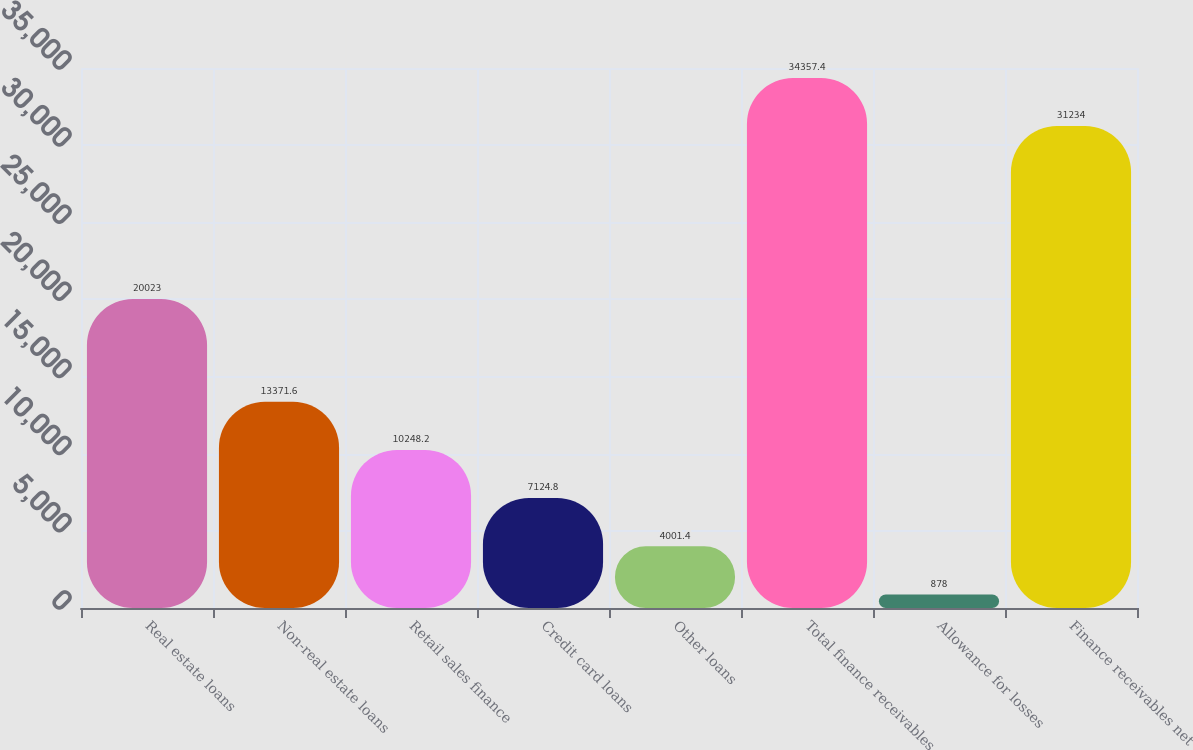Convert chart to OTSL. <chart><loc_0><loc_0><loc_500><loc_500><bar_chart><fcel>Real estate loans<fcel>Non-real estate loans<fcel>Retail sales finance<fcel>Credit card loans<fcel>Other loans<fcel>Total finance receivables<fcel>Allowance for losses<fcel>Finance receivables net<nl><fcel>20023<fcel>13371.6<fcel>10248.2<fcel>7124.8<fcel>4001.4<fcel>34357.4<fcel>878<fcel>31234<nl></chart> 